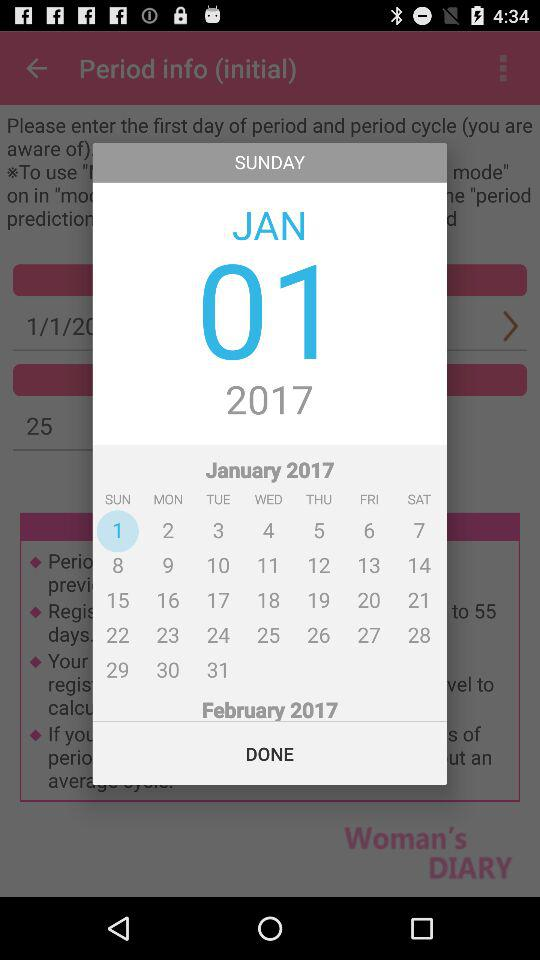What is the day on the 4th of January? The day is "Wednesday". 